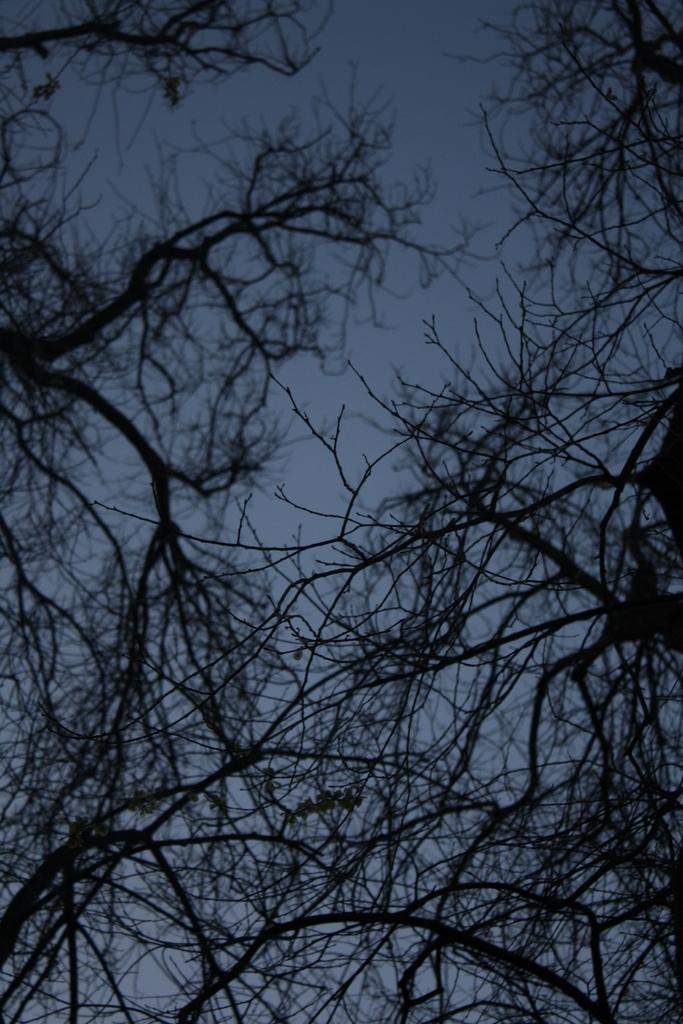How would you summarize this image in a sentence or two? The picture consists of trees and sky. 